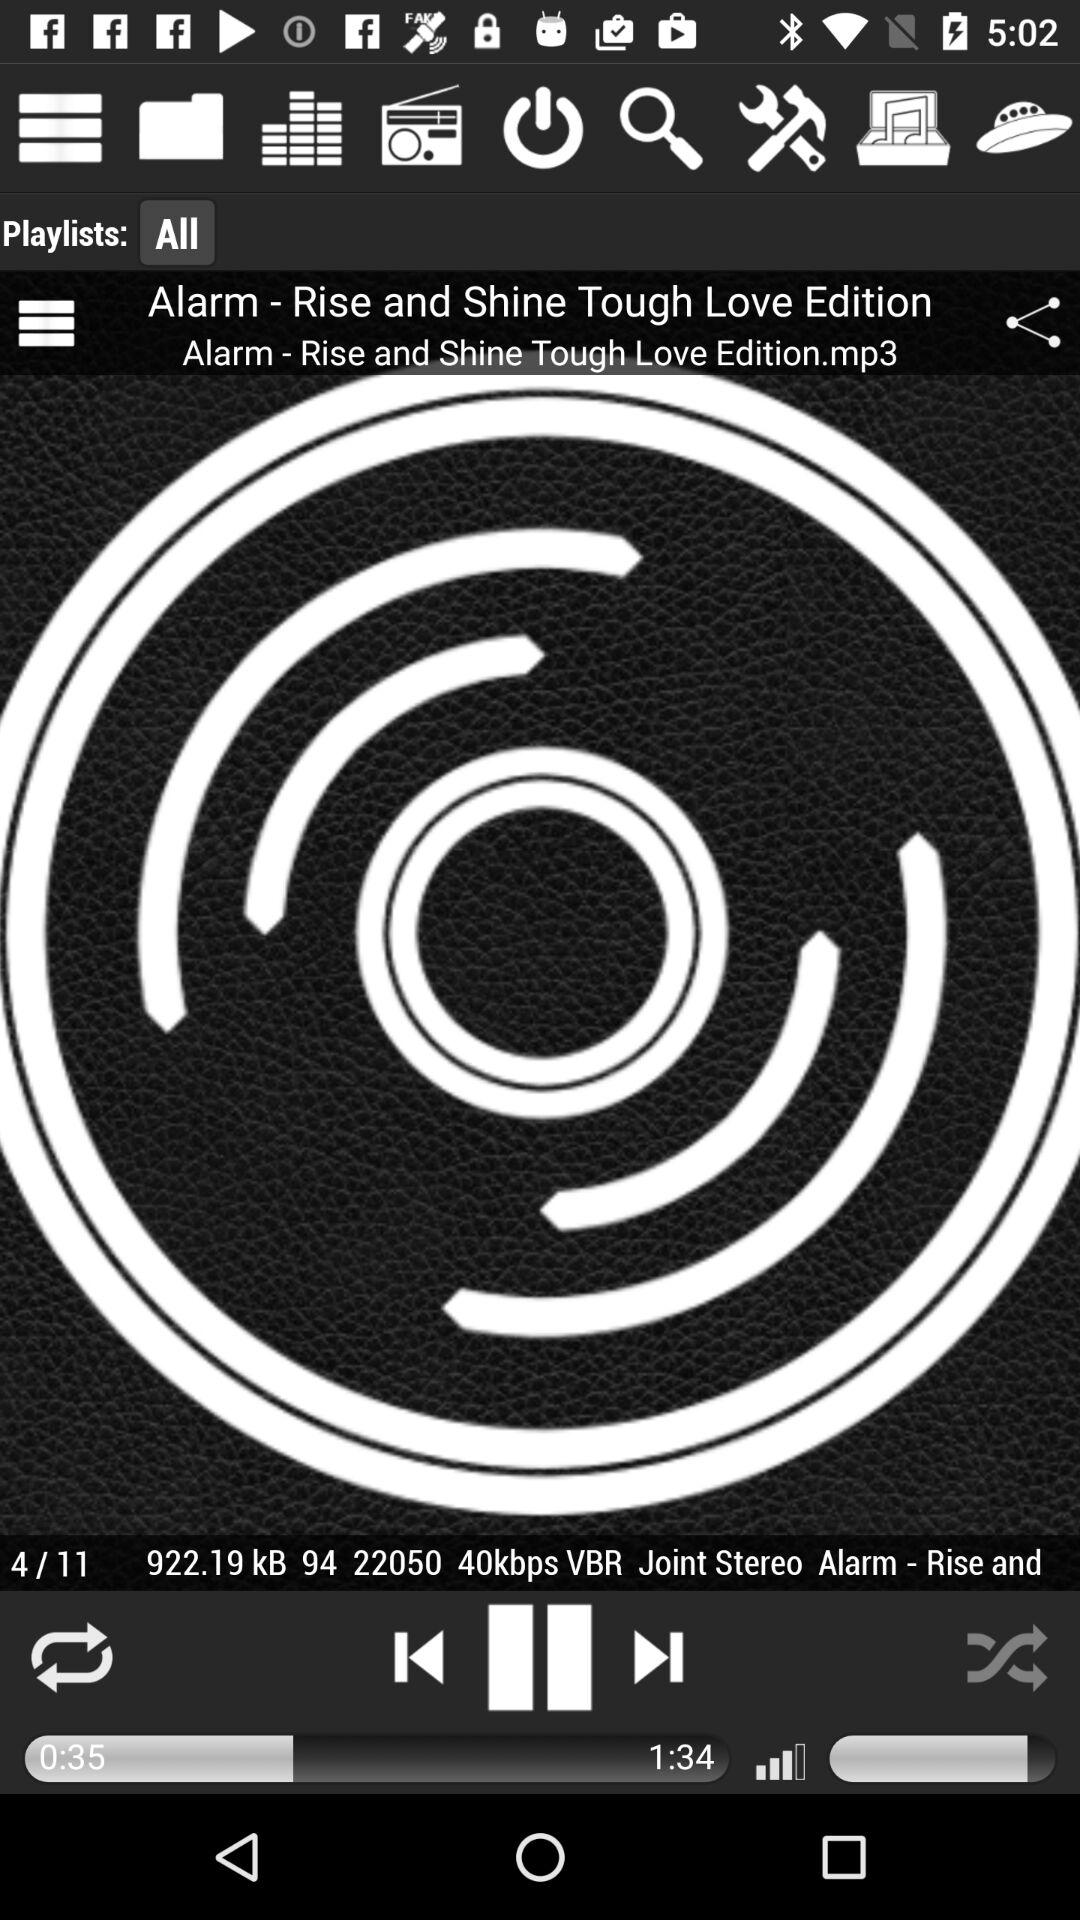What is the total number of audios? The total number of audios is 11. 